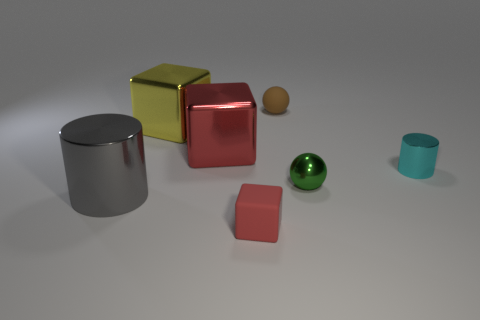There is a object that is the same color as the tiny rubber block; what material is it?
Give a very brief answer. Metal. What is the color of the object that is behind the tiny cube and in front of the green shiny ball?
Offer a very short reply. Gray. Is the color of the tiny metal object in front of the cyan cylinder the same as the tiny metal cylinder?
Your answer should be compact. No. There is a cyan object that is the same size as the red matte block; what shape is it?
Give a very brief answer. Cylinder. What number of other things are there of the same color as the small rubber ball?
Ensure brevity in your answer.  0. How many other things are made of the same material as the large gray cylinder?
Your answer should be very brief. 4. Does the red metal block have the same size as the thing in front of the gray cylinder?
Your response must be concise. No. What is the color of the large shiny cylinder?
Offer a very short reply. Gray. There is a matte object behind the red thing behind the tiny rubber thing on the left side of the tiny brown rubber object; what shape is it?
Ensure brevity in your answer.  Sphere. What material is the cylinder that is behind the cylinder in front of the tiny green shiny thing made of?
Make the answer very short. Metal. 